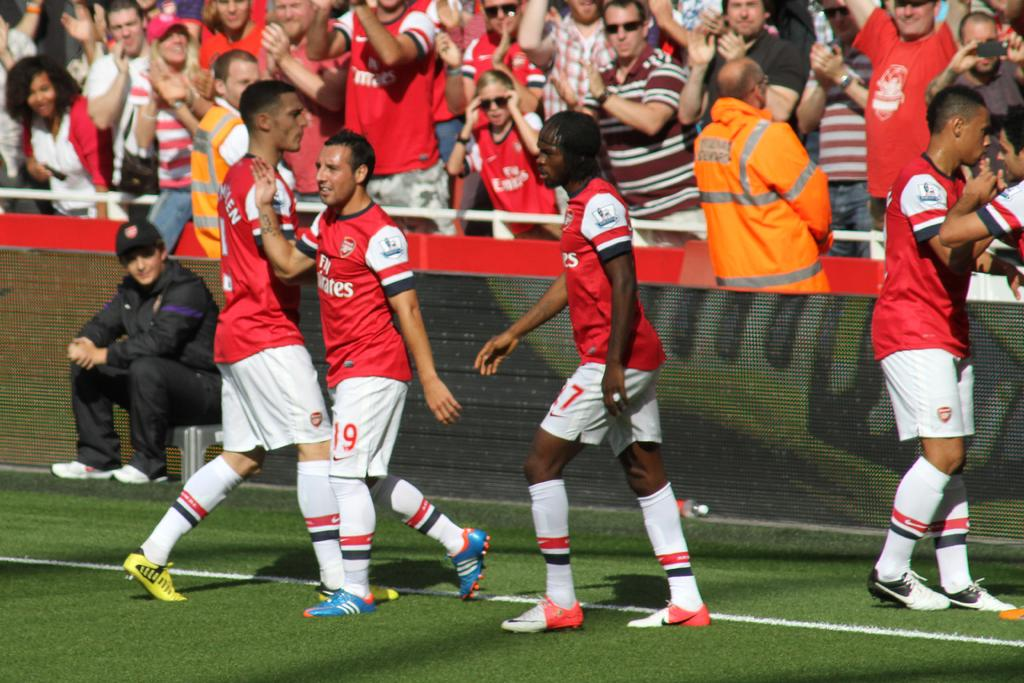<image>
Give a short and clear explanation of the subsequent image. A group of soccer players are standing by the crowd and their uniforms say Fly Emirates. 